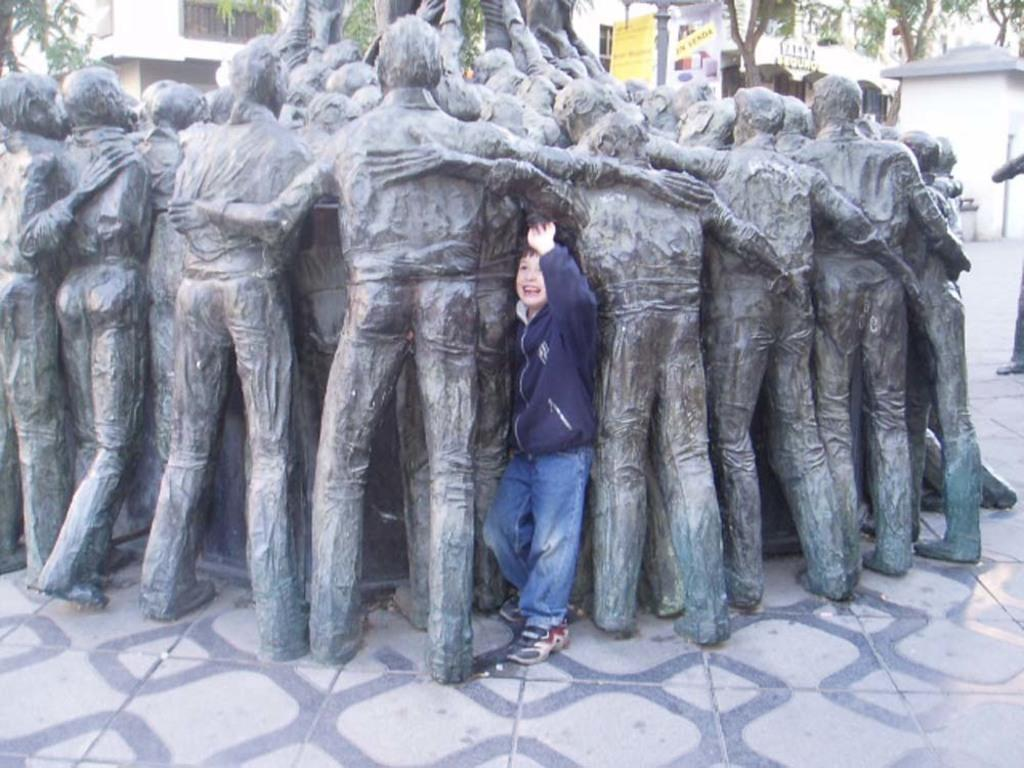Who is present in the image? There is a boy in the image. What is the boy wearing? The boy is wearing a jacket and shoes. Where is the boy standing? The boy is standing on the floor. What other objects or structures can be seen in the image? There is a statue, buildings, posters, and trees in the background. What type of yarn is being used to create the crowd in the image? There is no crowd present in the image, and therefore no yarn is being used. 